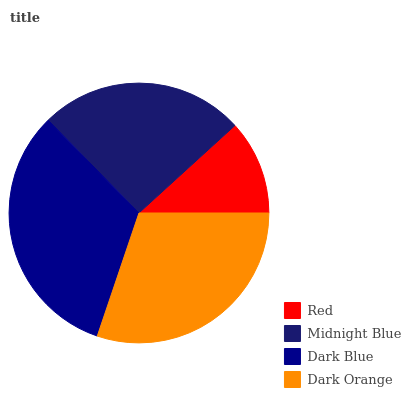Is Red the minimum?
Answer yes or no. Yes. Is Dark Blue the maximum?
Answer yes or no. Yes. Is Midnight Blue the minimum?
Answer yes or no. No. Is Midnight Blue the maximum?
Answer yes or no. No. Is Midnight Blue greater than Red?
Answer yes or no. Yes. Is Red less than Midnight Blue?
Answer yes or no. Yes. Is Red greater than Midnight Blue?
Answer yes or no. No. Is Midnight Blue less than Red?
Answer yes or no. No. Is Dark Orange the high median?
Answer yes or no. Yes. Is Midnight Blue the low median?
Answer yes or no. Yes. Is Red the high median?
Answer yes or no. No. Is Dark Orange the low median?
Answer yes or no. No. 